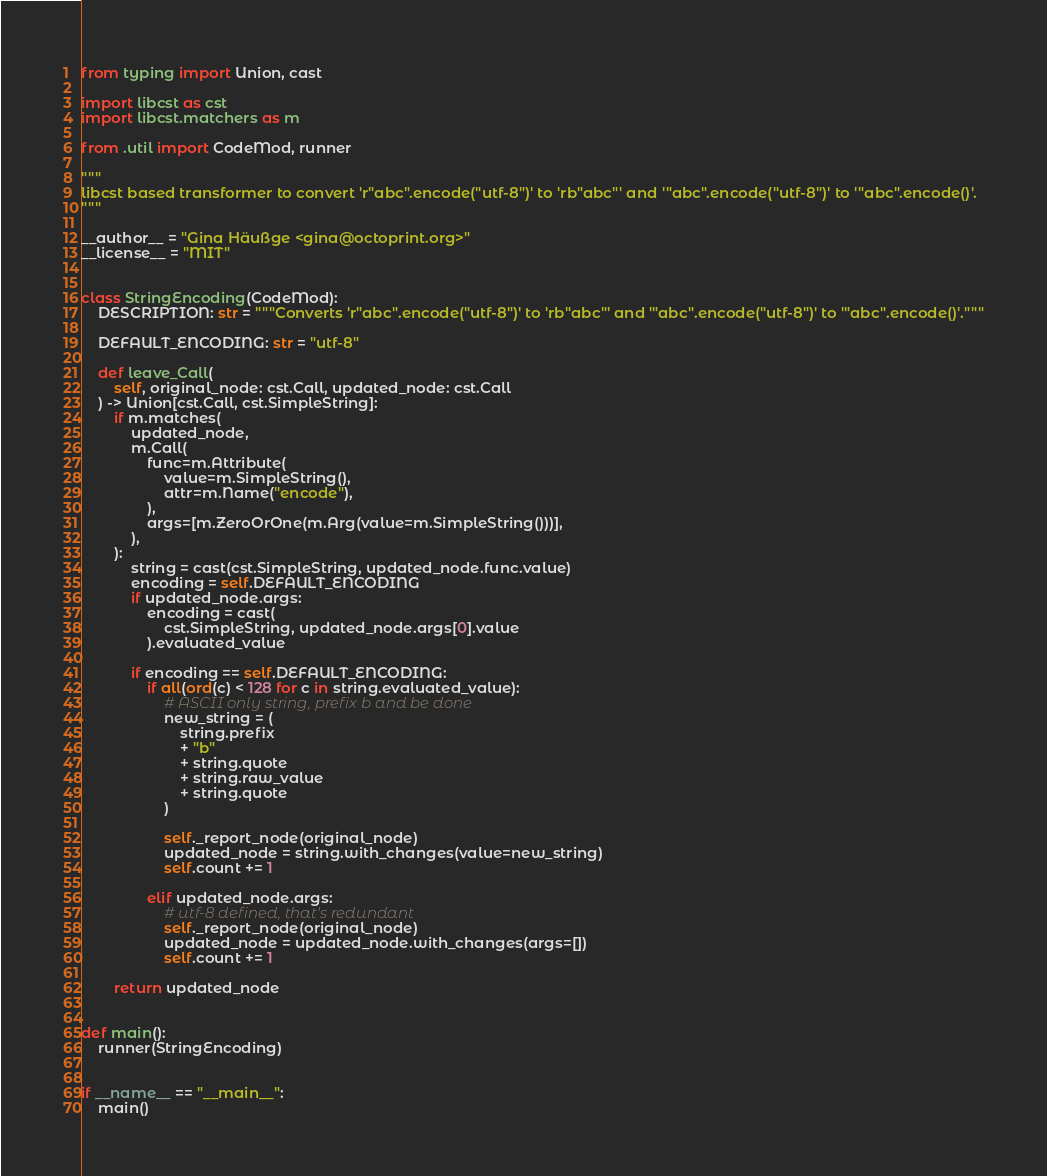<code> <loc_0><loc_0><loc_500><loc_500><_Python_>from typing import Union, cast

import libcst as cst
import libcst.matchers as m

from .util import CodeMod, runner

"""
libcst based transformer to convert 'r"abc".encode("utf-8")' to 'rb"abc"' and '"abc".encode("utf-8")' to '"abc".encode()'.
"""

__author__ = "Gina Häußge <gina@octoprint.org>"
__license__ = "MIT"


class StringEncoding(CodeMod):
    DESCRIPTION: str = """Converts 'r"abc".encode("utf-8")' to 'rb"abc"' and '"abc".encode("utf-8")' to '"abc".encode()'."""

    DEFAULT_ENCODING: str = "utf-8"

    def leave_Call(
        self, original_node: cst.Call, updated_node: cst.Call
    ) -> Union[cst.Call, cst.SimpleString]:
        if m.matches(
            updated_node,
            m.Call(
                func=m.Attribute(
                    value=m.SimpleString(),
                    attr=m.Name("encode"),
                ),
                args=[m.ZeroOrOne(m.Arg(value=m.SimpleString()))],
            ),
        ):
            string = cast(cst.SimpleString, updated_node.func.value)
            encoding = self.DEFAULT_ENCODING
            if updated_node.args:
                encoding = cast(
                    cst.SimpleString, updated_node.args[0].value
                ).evaluated_value

            if encoding == self.DEFAULT_ENCODING:
                if all(ord(c) < 128 for c in string.evaluated_value):
                    # ASCII only string, prefix b and be done
                    new_string = (
                        string.prefix
                        + "b"
                        + string.quote
                        + string.raw_value
                        + string.quote
                    )

                    self._report_node(original_node)
                    updated_node = string.with_changes(value=new_string)
                    self.count += 1

                elif updated_node.args:
                    # utf-8 defined, that's redundant
                    self._report_node(original_node)
                    updated_node = updated_node.with_changes(args=[])
                    self.count += 1

        return updated_node


def main():
    runner(StringEncoding)


if __name__ == "__main__":
    main()
</code> 